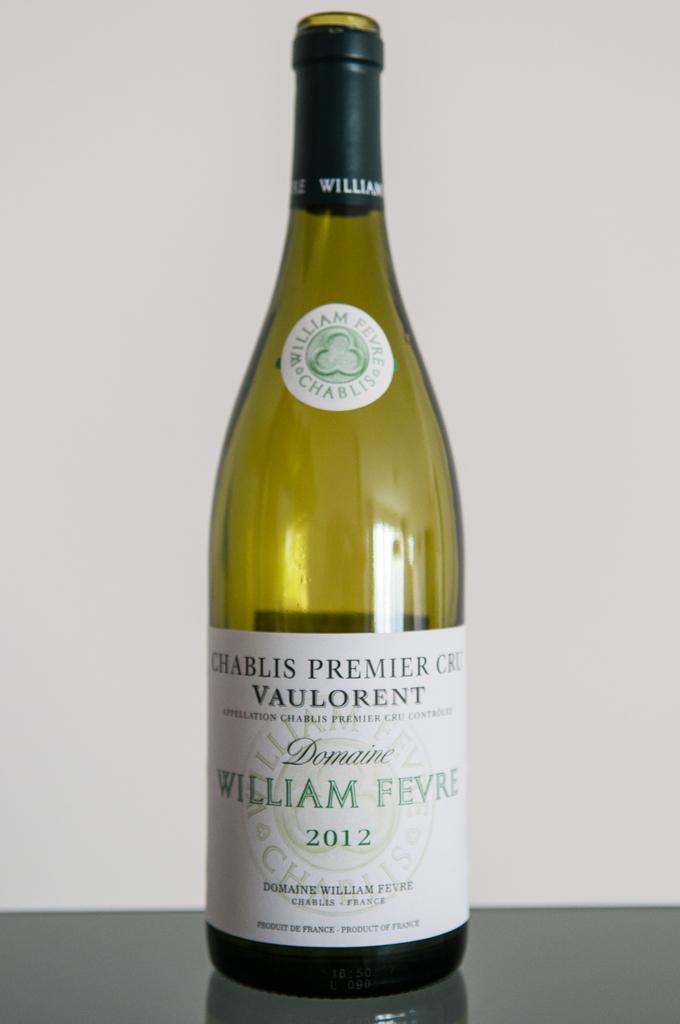In one or two sentences, can you explain what this image depicts? In the image there is a green color wine bottle on floor. it was written william fevre on it. And the background is white color. 